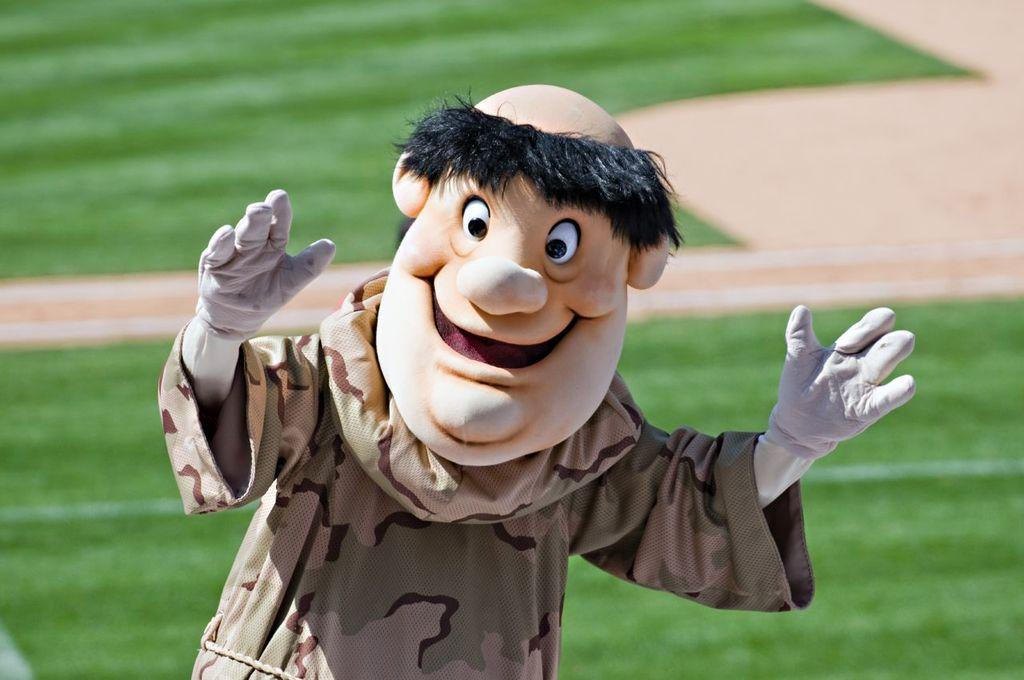Who or what is present in the image? There is a person in the image. What is the person wearing? The person is wearing a costume with different colors. What can be seen in the background of the image? There is green grass visible in the background of the image. How many trees are visible in the image? There are no trees visible in the image; only green grass is mentioned in the background. 